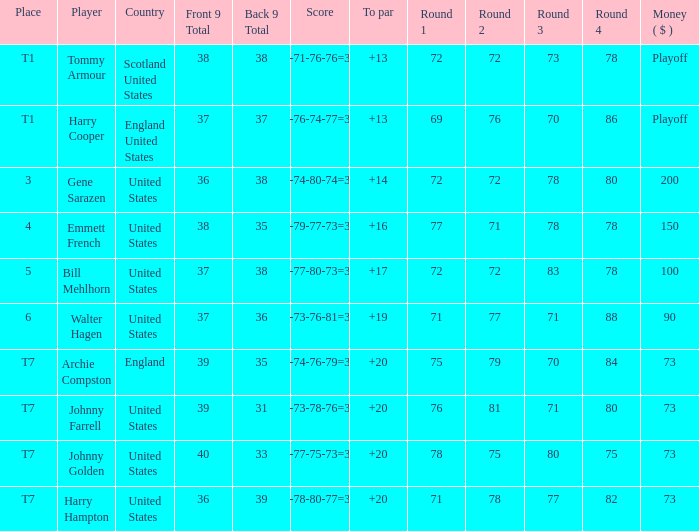What is the score for the United States when Harry Hampton is the player and the money is $73? 73-78-80-77=308. 